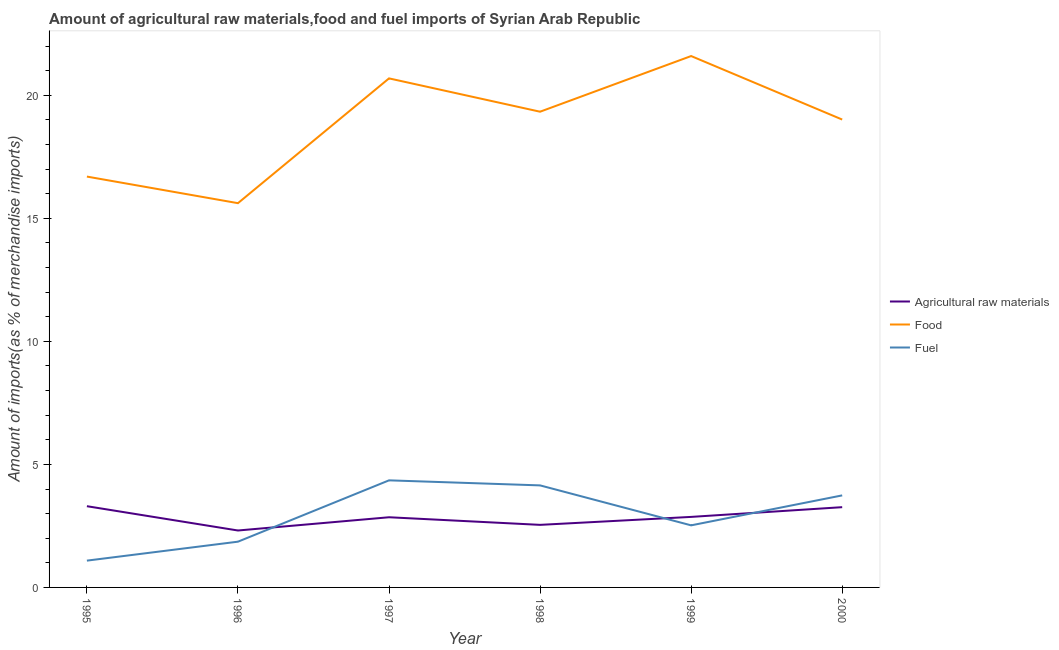Does the line corresponding to percentage of fuel imports intersect with the line corresponding to percentage of raw materials imports?
Keep it short and to the point. Yes. Is the number of lines equal to the number of legend labels?
Provide a succinct answer. Yes. What is the percentage of fuel imports in 1997?
Offer a very short reply. 4.35. Across all years, what is the maximum percentage of raw materials imports?
Provide a succinct answer. 3.3. Across all years, what is the minimum percentage of food imports?
Offer a terse response. 15.62. In which year was the percentage of raw materials imports minimum?
Make the answer very short. 1996. What is the total percentage of raw materials imports in the graph?
Offer a very short reply. 17.14. What is the difference between the percentage of fuel imports in 1996 and that in 1998?
Offer a very short reply. -2.29. What is the difference between the percentage of food imports in 1997 and the percentage of raw materials imports in 2000?
Give a very brief answer. 17.43. What is the average percentage of food imports per year?
Provide a succinct answer. 18.83. In the year 1997, what is the difference between the percentage of fuel imports and percentage of raw materials imports?
Give a very brief answer. 1.5. What is the ratio of the percentage of fuel imports in 1997 to that in 2000?
Your response must be concise. 1.16. Is the percentage of food imports in 1999 less than that in 2000?
Ensure brevity in your answer.  No. Is the difference between the percentage of fuel imports in 1998 and 2000 greater than the difference between the percentage of raw materials imports in 1998 and 2000?
Your response must be concise. Yes. What is the difference between the highest and the second highest percentage of raw materials imports?
Offer a terse response. 0.04. What is the difference between the highest and the lowest percentage of food imports?
Ensure brevity in your answer.  5.98. Is it the case that in every year, the sum of the percentage of raw materials imports and percentage of food imports is greater than the percentage of fuel imports?
Give a very brief answer. Yes. Is the percentage of food imports strictly greater than the percentage of fuel imports over the years?
Offer a terse response. Yes. Is the percentage of food imports strictly less than the percentage of raw materials imports over the years?
Offer a terse response. No. How many lines are there?
Keep it short and to the point. 3. How many years are there in the graph?
Give a very brief answer. 6. Are the values on the major ticks of Y-axis written in scientific E-notation?
Provide a short and direct response. No. Does the graph contain grids?
Provide a short and direct response. No. How are the legend labels stacked?
Your answer should be very brief. Vertical. What is the title of the graph?
Keep it short and to the point. Amount of agricultural raw materials,food and fuel imports of Syrian Arab Republic. Does "Primary" appear as one of the legend labels in the graph?
Ensure brevity in your answer.  No. What is the label or title of the X-axis?
Make the answer very short. Year. What is the label or title of the Y-axis?
Make the answer very short. Amount of imports(as % of merchandise imports). What is the Amount of imports(as % of merchandise imports) of Agricultural raw materials in 1995?
Keep it short and to the point. 3.3. What is the Amount of imports(as % of merchandise imports) of Food in 1995?
Your answer should be compact. 16.7. What is the Amount of imports(as % of merchandise imports) of Fuel in 1995?
Provide a succinct answer. 1.09. What is the Amount of imports(as % of merchandise imports) of Agricultural raw materials in 1996?
Your answer should be compact. 2.31. What is the Amount of imports(as % of merchandise imports) of Food in 1996?
Provide a succinct answer. 15.62. What is the Amount of imports(as % of merchandise imports) of Fuel in 1996?
Your response must be concise. 1.86. What is the Amount of imports(as % of merchandise imports) of Agricultural raw materials in 1997?
Give a very brief answer. 2.85. What is the Amount of imports(as % of merchandise imports) of Food in 1997?
Offer a terse response. 20.69. What is the Amount of imports(as % of merchandise imports) of Fuel in 1997?
Provide a short and direct response. 4.35. What is the Amount of imports(as % of merchandise imports) of Agricultural raw materials in 1998?
Provide a short and direct response. 2.54. What is the Amount of imports(as % of merchandise imports) in Food in 1998?
Make the answer very short. 19.33. What is the Amount of imports(as % of merchandise imports) in Fuel in 1998?
Offer a terse response. 4.15. What is the Amount of imports(as % of merchandise imports) of Agricultural raw materials in 1999?
Give a very brief answer. 2.87. What is the Amount of imports(as % of merchandise imports) in Food in 1999?
Provide a succinct answer. 21.6. What is the Amount of imports(as % of merchandise imports) in Fuel in 1999?
Offer a very short reply. 2.52. What is the Amount of imports(as % of merchandise imports) of Agricultural raw materials in 2000?
Provide a short and direct response. 3.26. What is the Amount of imports(as % of merchandise imports) in Food in 2000?
Make the answer very short. 19.02. What is the Amount of imports(as % of merchandise imports) in Fuel in 2000?
Provide a short and direct response. 3.74. Across all years, what is the maximum Amount of imports(as % of merchandise imports) in Agricultural raw materials?
Keep it short and to the point. 3.3. Across all years, what is the maximum Amount of imports(as % of merchandise imports) of Food?
Make the answer very short. 21.6. Across all years, what is the maximum Amount of imports(as % of merchandise imports) of Fuel?
Make the answer very short. 4.35. Across all years, what is the minimum Amount of imports(as % of merchandise imports) of Agricultural raw materials?
Keep it short and to the point. 2.31. Across all years, what is the minimum Amount of imports(as % of merchandise imports) of Food?
Make the answer very short. 15.62. Across all years, what is the minimum Amount of imports(as % of merchandise imports) of Fuel?
Your response must be concise. 1.09. What is the total Amount of imports(as % of merchandise imports) of Agricultural raw materials in the graph?
Provide a short and direct response. 17.14. What is the total Amount of imports(as % of merchandise imports) of Food in the graph?
Ensure brevity in your answer.  112.95. What is the total Amount of imports(as % of merchandise imports) of Fuel in the graph?
Your answer should be compact. 17.71. What is the difference between the Amount of imports(as % of merchandise imports) of Agricultural raw materials in 1995 and that in 1996?
Keep it short and to the point. 0.99. What is the difference between the Amount of imports(as % of merchandise imports) in Food in 1995 and that in 1996?
Offer a terse response. 1.08. What is the difference between the Amount of imports(as % of merchandise imports) of Fuel in 1995 and that in 1996?
Give a very brief answer. -0.77. What is the difference between the Amount of imports(as % of merchandise imports) in Agricultural raw materials in 1995 and that in 1997?
Your response must be concise. 0.45. What is the difference between the Amount of imports(as % of merchandise imports) in Food in 1995 and that in 1997?
Provide a short and direct response. -3.99. What is the difference between the Amount of imports(as % of merchandise imports) in Fuel in 1995 and that in 1997?
Make the answer very short. -3.26. What is the difference between the Amount of imports(as % of merchandise imports) in Agricultural raw materials in 1995 and that in 1998?
Make the answer very short. 0.76. What is the difference between the Amount of imports(as % of merchandise imports) in Food in 1995 and that in 1998?
Your response must be concise. -2.64. What is the difference between the Amount of imports(as % of merchandise imports) in Fuel in 1995 and that in 1998?
Your answer should be very brief. -3.06. What is the difference between the Amount of imports(as % of merchandise imports) of Agricultural raw materials in 1995 and that in 1999?
Provide a succinct answer. 0.44. What is the difference between the Amount of imports(as % of merchandise imports) of Food in 1995 and that in 1999?
Offer a very short reply. -4.9. What is the difference between the Amount of imports(as % of merchandise imports) in Fuel in 1995 and that in 1999?
Give a very brief answer. -1.43. What is the difference between the Amount of imports(as % of merchandise imports) in Agricultural raw materials in 1995 and that in 2000?
Make the answer very short. 0.04. What is the difference between the Amount of imports(as % of merchandise imports) in Food in 1995 and that in 2000?
Provide a short and direct response. -2.32. What is the difference between the Amount of imports(as % of merchandise imports) in Fuel in 1995 and that in 2000?
Provide a short and direct response. -2.65. What is the difference between the Amount of imports(as % of merchandise imports) in Agricultural raw materials in 1996 and that in 1997?
Provide a succinct answer. -0.54. What is the difference between the Amount of imports(as % of merchandise imports) of Food in 1996 and that in 1997?
Provide a succinct answer. -5.07. What is the difference between the Amount of imports(as % of merchandise imports) in Fuel in 1996 and that in 1997?
Provide a short and direct response. -2.49. What is the difference between the Amount of imports(as % of merchandise imports) in Agricultural raw materials in 1996 and that in 1998?
Make the answer very short. -0.23. What is the difference between the Amount of imports(as % of merchandise imports) in Food in 1996 and that in 1998?
Keep it short and to the point. -3.72. What is the difference between the Amount of imports(as % of merchandise imports) of Fuel in 1996 and that in 1998?
Ensure brevity in your answer.  -2.29. What is the difference between the Amount of imports(as % of merchandise imports) in Agricultural raw materials in 1996 and that in 1999?
Your answer should be compact. -0.55. What is the difference between the Amount of imports(as % of merchandise imports) in Food in 1996 and that in 1999?
Give a very brief answer. -5.98. What is the difference between the Amount of imports(as % of merchandise imports) in Fuel in 1996 and that in 1999?
Your response must be concise. -0.66. What is the difference between the Amount of imports(as % of merchandise imports) of Agricultural raw materials in 1996 and that in 2000?
Your answer should be compact. -0.95. What is the difference between the Amount of imports(as % of merchandise imports) of Food in 1996 and that in 2000?
Provide a short and direct response. -3.4. What is the difference between the Amount of imports(as % of merchandise imports) in Fuel in 1996 and that in 2000?
Offer a terse response. -1.88. What is the difference between the Amount of imports(as % of merchandise imports) of Agricultural raw materials in 1997 and that in 1998?
Ensure brevity in your answer.  0.31. What is the difference between the Amount of imports(as % of merchandise imports) of Food in 1997 and that in 1998?
Ensure brevity in your answer.  1.35. What is the difference between the Amount of imports(as % of merchandise imports) of Fuel in 1997 and that in 1998?
Keep it short and to the point. 0.2. What is the difference between the Amount of imports(as % of merchandise imports) of Agricultural raw materials in 1997 and that in 1999?
Provide a short and direct response. -0.01. What is the difference between the Amount of imports(as % of merchandise imports) in Food in 1997 and that in 1999?
Provide a succinct answer. -0.91. What is the difference between the Amount of imports(as % of merchandise imports) in Fuel in 1997 and that in 1999?
Offer a very short reply. 1.83. What is the difference between the Amount of imports(as % of merchandise imports) in Agricultural raw materials in 1997 and that in 2000?
Your response must be concise. -0.41. What is the difference between the Amount of imports(as % of merchandise imports) of Food in 1997 and that in 2000?
Keep it short and to the point. 1.67. What is the difference between the Amount of imports(as % of merchandise imports) in Fuel in 1997 and that in 2000?
Make the answer very short. 0.61. What is the difference between the Amount of imports(as % of merchandise imports) in Agricultural raw materials in 1998 and that in 1999?
Ensure brevity in your answer.  -0.32. What is the difference between the Amount of imports(as % of merchandise imports) in Food in 1998 and that in 1999?
Keep it short and to the point. -2.26. What is the difference between the Amount of imports(as % of merchandise imports) of Fuel in 1998 and that in 1999?
Offer a very short reply. 1.62. What is the difference between the Amount of imports(as % of merchandise imports) in Agricultural raw materials in 1998 and that in 2000?
Keep it short and to the point. -0.72. What is the difference between the Amount of imports(as % of merchandise imports) of Food in 1998 and that in 2000?
Keep it short and to the point. 0.32. What is the difference between the Amount of imports(as % of merchandise imports) of Fuel in 1998 and that in 2000?
Your response must be concise. 0.41. What is the difference between the Amount of imports(as % of merchandise imports) in Agricultural raw materials in 1999 and that in 2000?
Keep it short and to the point. -0.4. What is the difference between the Amount of imports(as % of merchandise imports) in Food in 1999 and that in 2000?
Provide a short and direct response. 2.58. What is the difference between the Amount of imports(as % of merchandise imports) in Fuel in 1999 and that in 2000?
Offer a terse response. -1.22. What is the difference between the Amount of imports(as % of merchandise imports) of Agricultural raw materials in 1995 and the Amount of imports(as % of merchandise imports) of Food in 1996?
Provide a short and direct response. -12.32. What is the difference between the Amount of imports(as % of merchandise imports) of Agricultural raw materials in 1995 and the Amount of imports(as % of merchandise imports) of Fuel in 1996?
Offer a very short reply. 1.44. What is the difference between the Amount of imports(as % of merchandise imports) of Food in 1995 and the Amount of imports(as % of merchandise imports) of Fuel in 1996?
Your response must be concise. 14.84. What is the difference between the Amount of imports(as % of merchandise imports) in Agricultural raw materials in 1995 and the Amount of imports(as % of merchandise imports) in Food in 1997?
Offer a very short reply. -17.39. What is the difference between the Amount of imports(as % of merchandise imports) in Agricultural raw materials in 1995 and the Amount of imports(as % of merchandise imports) in Fuel in 1997?
Keep it short and to the point. -1.05. What is the difference between the Amount of imports(as % of merchandise imports) of Food in 1995 and the Amount of imports(as % of merchandise imports) of Fuel in 1997?
Offer a very short reply. 12.35. What is the difference between the Amount of imports(as % of merchandise imports) of Agricultural raw materials in 1995 and the Amount of imports(as % of merchandise imports) of Food in 1998?
Your answer should be very brief. -16.03. What is the difference between the Amount of imports(as % of merchandise imports) of Agricultural raw materials in 1995 and the Amount of imports(as % of merchandise imports) of Fuel in 1998?
Offer a terse response. -0.85. What is the difference between the Amount of imports(as % of merchandise imports) in Food in 1995 and the Amount of imports(as % of merchandise imports) in Fuel in 1998?
Offer a very short reply. 12.55. What is the difference between the Amount of imports(as % of merchandise imports) of Agricultural raw materials in 1995 and the Amount of imports(as % of merchandise imports) of Food in 1999?
Your answer should be very brief. -18.29. What is the difference between the Amount of imports(as % of merchandise imports) in Agricultural raw materials in 1995 and the Amount of imports(as % of merchandise imports) in Fuel in 1999?
Make the answer very short. 0.78. What is the difference between the Amount of imports(as % of merchandise imports) in Food in 1995 and the Amount of imports(as % of merchandise imports) in Fuel in 1999?
Make the answer very short. 14.17. What is the difference between the Amount of imports(as % of merchandise imports) of Agricultural raw materials in 1995 and the Amount of imports(as % of merchandise imports) of Food in 2000?
Offer a very short reply. -15.71. What is the difference between the Amount of imports(as % of merchandise imports) in Agricultural raw materials in 1995 and the Amount of imports(as % of merchandise imports) in Fuel in 2000?
Make the answer very short. -0.44. What is the difference between the Amount of imports(as % of merchandise imports) in Food in 1995 and the Amount of imports(as % of merchandise imports) in Fuel in 2000?
Your answer should be very brief. 12.96. What is the difference between the Amount of imports(as % of merchandise imports) in Agricultural raw materials in 1996 and the Amount of imports(as % of merchandise imports) in Food in 1997?
Ensure brevity in your answer.  -18.38. What is the difference between the Amount of imports(as % of merchandise imports) of Agricultural raw materials in 1996 and the Amount of imports(as % of merchandise imports) of Fuel in 1997?
Provide a succinct answer. -2.04. What is the difference between the Amount of imports(as % of merchandise imports) of Food in 1996 and the Amount of imports(as % of merchandise imports) of Fuel in 1997?
Ensure brevity in your answer.  11.27. What is the difference between the Amount of imports(as % of merchandise imports) of Agricultural raw materials in 1996 and the Amount of imports(as % of merchandise imports) of Food in 1998?
Make the answer very short. -17.02. What is the difference between the Amount of imports(as % of merchandise imports) of Agricultural raw materials in 1996 and the Amount of imports(as % of merchandise imports) of Fuel in 1998?
Ensure brevity in your answer.  -1.83. What is the difference between the Amount of imports(as % of merchandise imports) of Food in 1996 and the Amount of imports(as % of merchandise imports) of Fuel in 1998?
Offer a terse response. 11.47. What is the difference between the Amount of imports(as % of merchandise imports) of Agricultural raw materials in 1996 and the Amount of imports(as % of merchandise imports) of Food in 1999?
Make the answer very short. -19.28. What is the difference between the Amount of imports(as % of merchandise imports) in Agricultural raw materials in 1996 and the Amount of imports(as % of merchandise imports) in Fuel in 1999?
Make the answer very short. -0.21. What is the difference between the Amount of imports(as % of merchandise imports) of Food in 1996 and the Amount of imports(as % of merchandise imports) of Fuel in 1999?
Provide a succinct answer. 13.09. What is the difference between the Amount of imports(as % of merchandise imports) in Agricultural raw materials in 1996 and the Amount of imports(as % of merchandise imports) in Food in 2000?
Your response must be concise. -16.7. What is the difference between the Amount of imports(as % of merchandise imports) in Agricultural raw materials in 1996 and the Amount of imports(as % of merchandise imports) in Fuel in 2000?
Provide a short and direct response. -1.43. What is the difference between the Amount of imports(as % of merchandise imports) in Food in 1996 and the Amount of imports(as % of merchandise imports) in Fuel in 2000?
Provide a short and direct response. 11.88. What is the difference between the Amount of imports(as % of merchandise imports) of Agricultural raw materials in 1997 and the Amount of imports(as % of merchandise imports) of Food in 1998?
Make the answer very short. -16.48. What is the difference between the Amount of imports(as % of merchandise imports) in Agricultural raw materials in 1997 and the Amount of imports(as % of merchandise imports) in Fuel in 1998?
Your answer should be compact. -1.3. What is the difference between the Amount of imports(as % of merchandise imports) in Food in 1997 and the Amount of imports(as % of merchandise imports) in Fuel in 1998?
Provide a succinct answer. 16.54. What is the difference between the Amount of imports(as % of merchandise imports) of Agricultural raw materials in 1997 and the Amount of imports(as % of merchandise imports) of Food in 1999?
Give a very brief answer. -18.74. What is the difference between the Amount of imports(as % of merchandise imports) of Agricultural raw materials in 1997 and the Amount of imports(as % of merchandise imports) of Fuel in 1999?
Make the answer very short. 0.33. What is the difference between the Amount of imports(as % of merchandise imports) in Food in 1997 and the Amount of imports(as % of merchandise imports) in Fuel in 1999?
Offer a terse response. 18.17. What is the difference between the Amount of imports(as % of merchandise imports) of Agricultural raw materials in 1997 and the Amount of imports(as % of merchandise imports) of Food in 2000?
Provide a short and direct response. -16.16. What is the difference between the Amount of imports(as % of merchandise imports) in Agricultural raw materials in 1997 and the Amount of imports(as % of merchandise imports) in Fuel in 2000?
Provide a succinct answer. -0.89. What is the difference between the Amount of imports(as % of merchandise imports) of Food in 1997 and the Amount of imports(as % of merchandise imports) of Fuel in 2000?
Your answer should be very brief. 16.95. What is the difference between the Amount of imports(as % of merchandise imports) of Agricultural raw materials in 1998 and the Amount of imports(as % of merchandise imports) of Food in 1999?
Your answer should be compact. -19.05. What is the difference between the Amount of imports(as % of merchandise imports) in Agricultural raw materials in 1998 and the Amount of imports(as % of merchandise imports) in Fuel in 1999?
Provide a short and direct response. 0.02. What is the difference between the Amount of imports(as % of merchandise imports) of Food in 1998 and the Amount of imports(as % of merchandise imports) of Fuel in 1999?
Ensure brevity in your answer.  16.81. What is the difference between the Amount of imports(as % of merchandise imports) of Agricultural raw materials in 1998 and the Amount of imports(as % of merchandise imports) of Food in 2000?
Keep it short and to the point. -16.47. What is the difference between the Amount of imports(as % of merchandise imports) of Agricultural raw materials in 1998 and the Amount of imports(as % of merchandise imports) of Fuel in 2000?
Make the answer very short. -1.2. What is the difference between the Amount of imports(as % of merchandise imports) in Food in 1998 and the Amount of imports(as % of merchandise imports) in Fuel in 2000?
Your answer should be very brief. 15.59. What is the difference between the Amount of imports(as % of merchandise imports) of Agricultural raw materials in 1999 and the Amount of imports(as % of merchandise imports) of Food in 2000?
Ensure brevity in your answer.  -16.15. What is the difference between the Amount of imports(as % of merchandise imports) in Agricultural raw materials in 1999 and the Amount of imports(as % of merchandise imports) in Fuel in 2000?
Offer a very short reply. -0.87. What is the difference between the Amount of imports(as % of merchandise imports) of Food in 1999 and the Amount of imports(as % of merchandise imports) of Fuel in 2000?
Give a very brief answer. 17.86. What is the average Amount of imports(as % of merchandise imports) in Agricultural raw materials per year?
Make the answer very short. 2.86. What is the average Amount of imports(as % of merchandise imports) in Food per year?
Provide a succinct answer. 18.83. What is the average Amount of imports(as % of merchandise imports) in Fuel per year?
Offer a very short reply. 2.95. In the year 1995, what is the difference between the Amount of imports(as % of merchandise imports) of Agricultural raw materials and Amount of imports(as % of merchandise imports) of Food?
Make the answer very short. -13.4. In the year 1995, what is the difference between the Amount of imports(as % of merchandise imports) of Agricultural raw materials and Amount of imports(as % of merchandise imports) of Fuel?
Offer a very short reply. 2.21. In the year 1995, what is the difference between the Amount of imports(as % of merchandise imports) of Food and Amount of imports(as % of merchandise imports) of Fuel?
Offer a terse response. 15.61. In the year 1996, what is the difference between the Amount of imports(as % of merchandise imports) of Agricultural raw materials and Amount of imports(as % of merchandise imports) of Food?
Provide a succinct answer. -13.3. In the year 1996, what is the difference between the Amount of imports(as % of merchandise imports) in Agricultural raw materials and Amount of imports(as % of merchandise imports) in Fuel?
Provide a succinct answer. 0.45. In the year 1996, what is the difference between the Amount of imports(as % of merchandise imports) in Food and Amount of imports(as % of merchandise imports) in Fuel?
Offer a very short reply. 13.76. In the year 1997, what is the difference between the Amount of imports(as % of merchandise imports) of Agricultural raw materials and Amount of imports(as % of merchandise imports) of Food?
Your answer should be compact. -17.84. In the year 1997, what is the difference between the Amount of imports(as % of merchandise imports) in Agricultural raw materials and Amount of imports(as % of merchandise imports) in Fuel?
Provide a short and direct response. -1.5. In the year 1997, what is the difference between the Amount of imports(as % of merchandise imports) of Food and Amount of imports(as % of merchandise imports) of Fuel?
Your response must be concise. 16.34. In the year 1998, what is the difference between the Amount of imports(as % of merchandise imports) in Agricultural raw materials and Amount of imports(as % of merchandise imports) in Food?
Your answer should be compact. -16.79. In the year 1998, what is the difference between the Amount of imports(as % of merchandise imports) in Agricultural raw materials and Amount of imports(as % of merchandise imports) in Fuel?
Provide a succinct answer. -1.6. In the year 1998, what is the difference between the Amount of imports(as % of merchandise imports) in Food and Amount of imports(as % of merchandise imports) in Fuel?
Make the answer very short. 15.19. In the year 1999, what is the difference between the Amount of imports(as % of merchandise imports) of Agricultural raw materials and Amount of imports(as % of merchandise imports) of Food?
Your answer should be compact. -18.73. In the year 1999, what is the difference between the Amount of imports(as % of merchandise imports) of Agricultural raw materials and Amount of imports(as % of merchandise imports) of Fuel?
Offer a terse response. 0.34. In the year 1999, what is the difference between the Amount of imports(as % of merchandise imports) in Food and Amount of imports(as % of merchandise imports) in Fuel?
Ensure brevity in your answer.  19.07. In the year 2000, what is the difference between the Amount of imports(as % of merchandise imports) of Agricultural raw materials and Amount of imports(as % of merchandise imports) of Food?
Ensure brevity in your answer.  -15.75. In the year 2000, what is the difference between the Amount of imports(as % of merchandise imports) of Agricultural raw materials and Amount of imports(as % of merchandise imports) of Fuel?
Your response must be concise. -0.48. In the year 2000, what is the difference between the Amount of imports(as % of merchandise imports) in Food and Amount of imports(as % of merchandise imports) in Fuel?
Provide a short and direct response. 15.28. What is the ratio of the Amount of imports(as % of merchandise imports) in Agricultural raw materials in 1995 to that in 1996?
Keep it short and to the point. 1.43. What is the ratio of the Amount of imports(as % of merchandise imports) in Food in 1995 to that in 1996?
Ensure brevity in your answer.  1.07. What is the ratio of the Amount of imports(as % of merchandise imports) in Fuel in 1995 to that in 1996?
Provide a short and direct response. 0.59. What is the ratio of the Amount of imports(as % of merchandise imports) of Agricultural raw materials in 1995 to that in 1997?
Your answer should be compact. 1.16. What is the ratio of the Amount of imports(as % of merchandise imports) of Food in 1995 to that in 1997?
Your response must be concise. 0.81. What is the ratio of the Amount of imports(as % of merchandise imports) in Fuel in 1995 to that in 1997?
Your answer should be compact. 0.25. What is the ratio of the Amount of imports(as % of merchandise imports) of Agricultural raw materials in 1995 to that in 1998?
Your answer should be compact. 1.3. What is the ratio of the Amount of imports(as % of merchandise imports) in Food in 1995 to that in 1998?
Ensure brevity in your answer.  0.86. What is the ratio of the Amount of imports(as % of merchandise imports) of Fuel in 1995 to that in 1998?
Offer a terse response. 0.26. What is the ratio of the Amount of imports(as % of merchandise imports) of Agricultural raw materials in 1995 to that in 1999?
Make the answer very short. 1.15. What is the ratio of the Amount of imports(as % of merchandise imports) in Food in 1995 to that in 1999?
Your answer should be very brief. 0.77. What is the ratio of the Amount of imports(as % of merchandise imports) of Fuel in 1995 to that in 1999?
Make the answer very short. 0.43. What is the ratio of the Amount of imports(as % of merchandise imports) in Agricultural raw materials in 1995 to that in 2000?
Give a very brief answer. 1.01. What is the ratio of the Amount of imports(as % of merchandise imports) of Food in 1995 to that in 2000?
Your response must be concise. 0.88. What is the ratio of the Amount of imports(as % of merchandise imports) in Fuel in 1995 to that in 2000?
Your response must be concise. 0.29. What is the ratio of the Amount of imports(as % of merchandise imports) of Agricultural raw materials in 1996 to that in 1997?
Your answer should be compact. 0.81. What is the ratio of the Amount of imports(as % of merchandise imports) in Food in 1996 to that in 1997?
Provide a short and direct response. 0.75. What is the ratio of the Amount of imports(as % of merchandise imports) of Fuel in 1996 to that in 1997?
Your answer should be compact. 0.43. What is the ratio of the Amount of imports(as % of merchandise imports) of Agricultural raw materials in 1996 to that in 1998?
Provide a short and direct response. 0.91. What is the ratio of the Amount of imports(as % of merchandise imports) of Food in 1996 to that in 1998?
Give a very brief answer. 0.81. What is the ratio of the Amount of imports(as % of merchandise imports) of Fuel in 1996 to that in 1998?
Your answer should be very brief. 0.45. What is the ratio of the Amount of imports(as % of merchandise imports) of Agricultural raw materials in 1996 to that in 1999?
Offer a terse response. 0.81. What is the ratio of the Amount of imports(as % of merchandise imports) of Food in 1996 to that in 1999?
Your response must be concise. 0.72. What is the ratio of the Amount of imports(as % of merchandise imports) of Fuel in 1996 to that in 1999?
Your answer should be compact. 0.74. What is the ratio of the Amount of imports(as % of merchandise imports) in Agricultural raw materials in 1996 to that in 2000?
Your answer should be compact. 0.71. What is the ratio of the Amount of imports(as % of merchandise imports) of Food in 1996 to that in 2000?
Keep it short and to the point. 0.82. What is the ratio of the Amount of imports(as % of merchandise imports) in Fuel in 1996 to that in 2000?
Ensure brevity in your answer.  0.5. What is the ratio of the Amount of imports(as % of merchandise imports) of Agricultural raw materials in 1997 to that in 1998?
Offer a very short reply. 1.12. What is the ratio of the Amount of imports(as % of merchandise imports) of Food in 1997 to that in 1998?
Make the answer very short. 1.07. What is the ratio of the Amount of imports(as % of merchandise imports) of Fuel in 1997 to that in 1998?
Your response must be concise. 1.05. What is the ratio of the Amount of imports(as % of merchandise imports) in Food in 1997 to that in 1999?
Make the answer very short. 0.96. What is the ratio of the Amount of imports(as % of merchandise imports) in Fuel in 1997 to that in 1999?
Make the answer very short. 1.72. What is the ratio of the Amount of imports(as % of merchandise imports) of Agricultural raw materials in 1997 to that in 2000?
Your response must be concise. 0.87. What is the ratio of the Amount of imports(as % of merchandise imports) in Food in 1997 to that in 2000?
Provide a succinct answer. 1.09. What is the ratio of the Amount of imports(as % of merchandise imports) of Fuel in 1997 to that in 2000?
Offer a very short reply. 1.16. What is the ratio of the Amount of imports(as % of merchandise imports) in Agricultural raw materials in 1998 to that in 1999?
Give a very brief answer. 0.89. What is the ratio of the Amount of imports(as % of merchandise imports) in Food in 1998 to that in 1999?
Your answer should be compact. 0.9. What is the ratio of the Amount of imports(as % of merchandise imports) in Fuel in 1998 to that in 1999?
Your answer should be compact. 1.64. What is the ratio of the Amount of imports(as % of merchandise imports) in Agricultural raw materials in 1998 to that in 2000?
Keep it short and to the point. 0.78. What is the ratio of the Amount of imports(as % of merchandise imports) in Food in 1998 to that in 2000?
Make the answer very short. 1.02. What is the ratio of the Amount of imports(as % of merchandise imports) in Fuel in 1998 to that in 2000?
Your answer should be very brief. 1.11. What is the ratio of the Amount of imports(as % of merchandise imports) of Agricultural raw materials in 1999 to that in 2000?
Your response must be concise. 0.88. What is the ratio of the Amount of imports(as % of merchandise imports) of Food in 1999 to that in 2000?
Your answer should be compact. 1.14. What is the ratio of the Amount of imports(as % of merchandise imports) of Fuel in 1999 to that in 2000?
Offer a very short reply. 0.67. What is the difference between the highest and the second highest Amount of imports(as % of merchandise imports) in Agricultural raw materials?
Ensure brevity in your answer.  0.04. What is the difference between the highest and the second highest Amount of imports(as % of merchandise imports) of Food?
Offer a terse response. 0.91. What is the difference between the highest and the second highest Amount of imports(as % of merchandise imports) of Fuel?
Make the answer very short. 0.2. What is the difference between the highest and the lowest Amount of imports(as % of merchandise imports) of Agricultural raw materials?
Your answer should be very brief. 0.99. What is the difference between the highest and the lowest Amount of imports(as % of merchandise imports) in Food?
Keep it short and to the point. 5.98. What is the difference between the highest and the lowest Amount of imports(as % of merchandise imports) in Fuel?
Keep it short and to the point. 3.26. 